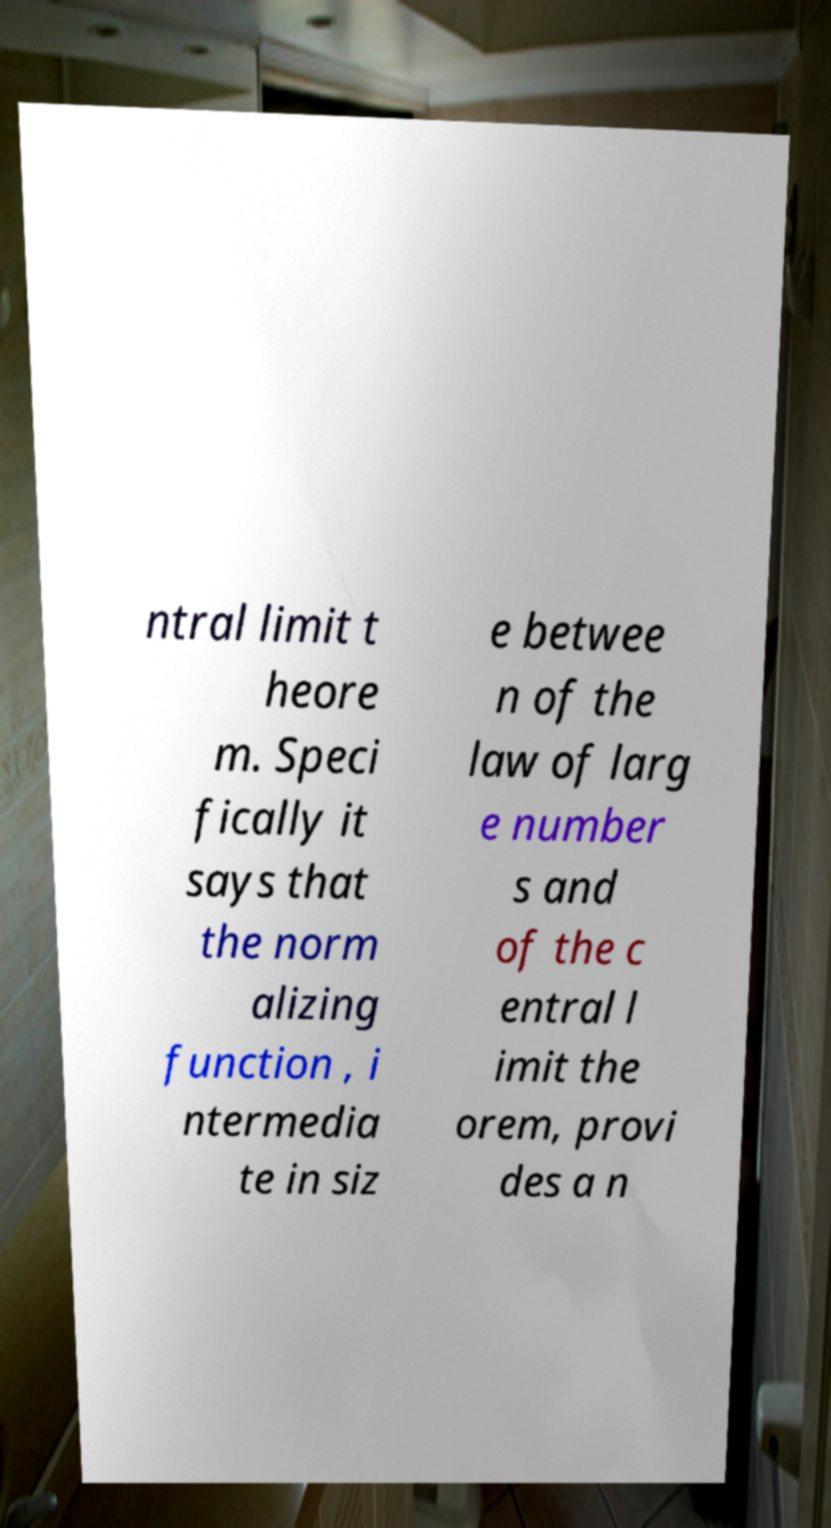Please identify and transcribe the text found in this image. ntral limit t heore m. Speci fically it says that the norm alizing function , i ntermedia te in siz e betwee n of the law of larg e number s and of the c entral l imit the orem, provi des a n 